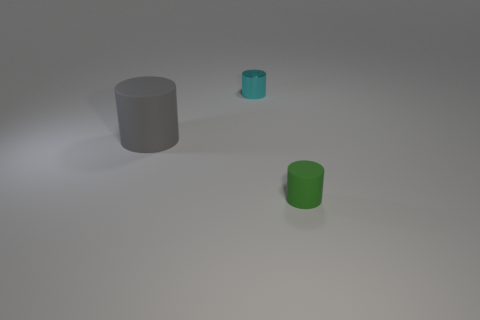What's the texture of the objects? The objects have a smooth, matte finish. The cyan object reflects light in a manner that suggests it could have a slightly metallic texture, while the other two look more like painted or plastic surfaces. 